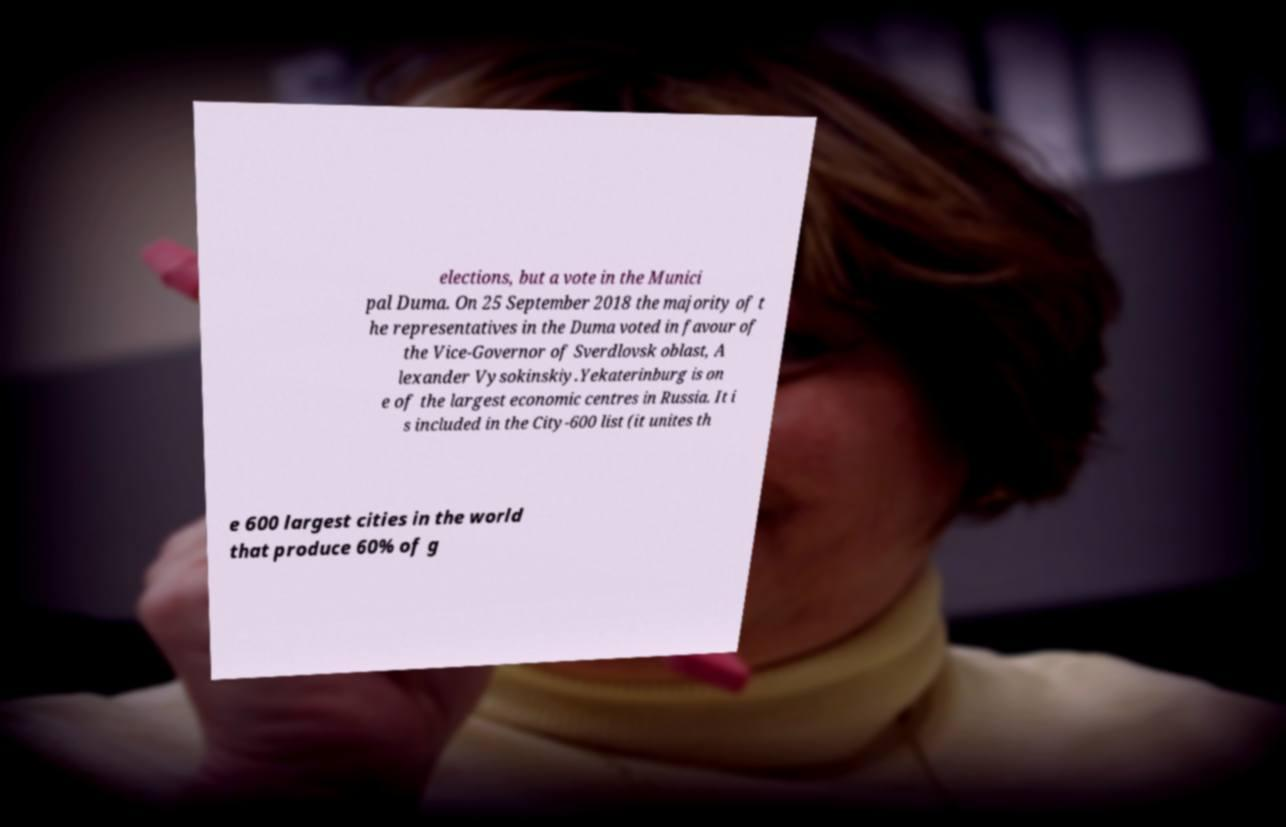Please identify and transcribe the text found in this image. elections, but a vote in the Munici pal Duma. On 25 September 2018 the majority of t he representatives in the Duma voted in favour of the Vice-Governor of Sverdlovsk oblast, A lexander Vysokinskiy.Yekaterinburg is on e of the largest economic centres in Russia. It i s included in the City-600 list (it unites th e 600 largest cities in the world that produce 60% of g 